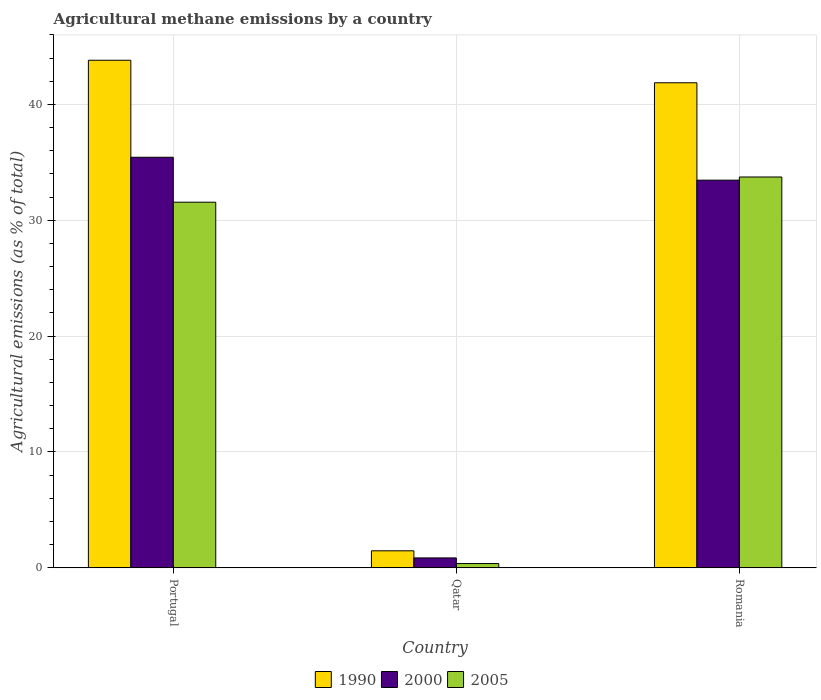How many different coloured bars are there?
Your response must be concise. 3. What is the label of the 3rd group of bars from the left?
Your response must be concise. Romania. In how many cases, is the number of bars for a given country not equal to the number of legend labels?
Your response must be concise. 0. What is the amount of agricultural methane emitted in 1990 in Romania?
Provide a succinct answer. 41.87. Across all countries, what is the maximum amount of agricultural methane emitted in 2005?
Keep it short and to the point. 33.74. Across all countries, what is the minimum amount of agricultural methane emitted in 1990?
Ensure brevity in your answer.  1.46. In which country was the amount of agricultural methane emitted in 2000 maximum?
Offer a very short reply. Portugal. In which country was the amount of agricultural methane emitted in 2005 minimum?
Your answer should be very brief. Qatar. What is the total amount of agricultural methane emitted in 2000 in the graph?
Ensure brevity in your answer.  69.75. What is the difference between the amount of agricultural methane emitted in 2005 in Qatar and that in Romania?
Your answer should be compact. -33.38. What is the difference between the amount of agricultural methane emitted in 2000 in Romania and the amount of agricultural methane emitted in 2005 in Qatar?
Ensure brevity in your answer.  33.1. What is the average amount of agricultural methane emitted in 2005 per country?
Your answer should be very brief. 21.89. What is the difference between the amount of agricultural methane emitted of/in 2005 and amount of agricultural methane emitted of/in 2000 in Romania?
Provide a short and direct response. 0.27. In how many countries, is the amount of agricultural methane emitted in 2005 greater than 2 %?
Keep it short and to the point. 2. What is the ratio of the amount of agricultural methane emitted in 2000 in Portugal to that in Qatar?
Ensure brevity in your answer.  41.75. Is the amount of agricultural methane emitted in 2000 in Portugal less than that in Romania?
Offer a very short reply. No. Is the difference between the amount of agricultural methane emitted in 2005 in Portugal and Romania greater than the difference between the amount of agricultural methane emitted in 2000 in Portugal and Romania?
Provide a succinct answer. No. What is the difference between the highest and the second highest amount of agricultural methane emitted in 2005?
Offer a very short reply. -33.38. What is the difference between the highest and the lowest amount of agricultural methane emitted in 2000?
Ensure brevity in your answer.  34.59. In how many countries, is the amount of agricultural methane emitted in 2005 greater than the average amount of agricultural methane emitted in 2005 taken over all countries?
Ensure brevity in your answer.  2. Is the sum of the amount of agricultural methane emitted in 2000 in Portugal and Romania greater than the maximum amount of agricultural methane emitted in 2005 across all countries?
Your answer should be compact. Yes. What does the 2nd bar from the left in Qatar represents?
Offer a very short reply. 2000. How many bars are there?
Your response must be concise. 9. Are all the bars in the graph horizontal?
Your answer should be compact. No. How many countries are there in the graph?
Offer a terse response. 3. Where does the legend appear in the graph?
Keep it short and to the point. Bottom center. How are the legend labels stacked?
Provide a succinct answer. Horizontal. What is the title of the graph?
Keep it short and to the point. Agricultural methane emissions by a country. What is the label or title of the X-axis?
Offer a very short reply. Country. What is the label or title of the Y-axis?
Your response must be concise. Agricultural emissions (as % of total). What is the Agricultural emissions (as % of total) of 1990 in Portugal?
Keep it short and to the point. 43.82. What is the Agricultural emissions (as % of total) of 2000 in Portugal?
Provide a short and direct response. 35.44. What is the Agricultural emissions (as % of total) of 2005 in Portugal?
Your response must be concise. 31.56. What is the Agricultural emissions (as % of total) in 1990 in Qatar?
Offer a very short reply. 1.46. What is the Agricultural emissions (as % of total) in 2000 in Qatar?
Ensure brevity in your answer.  0.85. What is the Agricultural emissions (as % of total) in 2005 in Qatar?
Your answer should be very brief. 0.36. What is the Agricultural emissions (as % of total) of 1990 in Romania?
Your response must be concise. 41.87. What is the Agricultural emissions (as % of total) in 2000 in Romania?
Your answer should be compact. 33.46. What is the Agricultural emissions (as % of total) of 2005 in Romania?
Your response must be concise. 33.74. Across all countries, what is the maximum Agricultural emissions (as % of total) in 1990?
Your answer should be very brief. 43.82. Across all countries, what is the maximum Agricultural emissions (as % of total) of 2000?
Keep it short and to the point. 35.44. Across all countries, what is the maximum Agricultural emissions (as % of total) in 2005?
Offer a very short reply. 33.74. Across all countries, what is the minimum Agricultural emissions (as % of total) in 1990?
Offer a very short reply. 1.46. Across all countries, what is the minimum Agricultural emissions (as % of total) of 2000?
Offer a very short reply. 0.85. Across all countries, what is the minimum Agricultural emissions (as % of total) in 2005?
Provide a succinct answer. 0.36. What is the total Agricultural emissions (as % of total) of 1990 in the graph?
Provide a succinct answer. 87.15. What is the total Agricultural emissions (as % of total) of 2000 in the graph?
Your answer should be very brief. 69.75. What is the total Agricultural emissions (as % of total) in 2005 in the graph?
Provide a succinct answer. 65.66. What is the difference between the Agricultural emissions (as % of total) of 1990 in Portugal and that in Qatar?
Keep it short and to the point. 42.35. What is the difference between the Agricultural emissions (as % of total) of 2000 in Portugal and that in Qatar?
Give a very brief answer. 34.59. What is the difference between the Agricultural emissions (as % of total) of 2005 in Portugal and that in Qatar?
Offer a very short reply. 31.2. What is the difference between the Agricultural emissions (as % of total) in 1990 in Portugal and that in Romania?
Provide a short and direct response. 1.94. What is the difference between the Agricultural emissions (as % of total) in 2000 in Portugal and that in Romania?
Make the answer very short. 1.98. What is the difference between the Agricultural emissions (as % of total) of 2005 in Portugal and that in Romania?
Give a very brief answer. -2.18. What is the difference between the Agricultural emissions (as % of total) in 1990 in Qatar and that in Romania?
Offer a terse response. -40.41. What is the difference between the Agricultural emissions (as % of total) of 2000 in Qatar and that in Romania?
Offer a terse response. -32.62. What is the difference between the Agricultural emissions (as % of total) of 2005 in Qatar and that in Romania?
Offer a very short reply. -33.38. What is the difference between the Agricultural emissions (as % of total) in 1990 in Portugal and the Agricultural emissions (as % of total) in 2000 in Qatar?
Provide a short and direct response. 42.97. What is the difference between the Agricultural emissions (as % of total) in 1990 in Portugal and the Agricultural emissions (as % of total) in 2005 in Qatar?
Your response must be concise. 43.45. What is the difference between the Agricultural emissions (as % of total) in 2000 in Portugal and the Agricultural emissions (as % of total) in 2005 in Qatar?
Offer a very short reply. 35.08. What is the difference between the Agricultural emissions (as % of total) of 1990 in Portugal and the Agricultural emissions (as % of total) of 2000 in Romania?
Make the answer very short. 10.35. What is the difference between the Agricultural emissions (as % of total) in 1990 in Portugal and the Agricultural emissions (as % of total) in 2005 in Romania?
Ensure brevity in your answer.  10.08. What is the difference between the Agricultural emissions (as % of total) of 2000 in Portugal and the Agricultural emissions (as % of total) of 2005 in Romania?
Ensure brevity in your answer.  1.7. What is the difference between the Agricultural emissions (as % of total) of 1990 in Qatar and the Agricultural emissions (as % of total) of 2000 in Romania?
Provide a short and direct response. -32. What is the difference between the Agricultural emissions (as % of total) in 1990 in Qatar and the Agricultural emissions (as % of total) in 2005 in Romania?
Provide a succinct answer. -32.27. What is the difference between the Agricultural emissions (as % of total) of 2000 in Qatar and the Agricultural emissions (as % of total) of 2005 in Romania?
Offer a very short reply. -32.89. What is the average Agricultural emissions (as % of total) in 1990 per country?
Provide a short and direct response. 29.05. What is the average Agricultural emissions (as % of total) in 2000 per country?
Provide a short and direct response. 23.25. What is the average Agricultural emissions (as % of total) in 2005 per country?
Keep it short and to the point. 21.89. What is the difference between the Agricultural emissions (as % of total) of 1990 and Agricultural emissions (as % of total) of 2000 in Portugal?
Your response must be concise. 8.38. What is the difference between the Agricultural emissions (as % of total) in 1990 and Agricultural emissions (as % of total) in 2005 in Portugal?
Ensure brevity in your answer.  12.26. What is the difference between the Agricultural emissions (as % of total) in 2000 and Agricultural emissions (as % of total) in 2005 in Portugal?
Provide a short and direct response. 3.88. What is the difference between the Agricultural emissions (as % of total) in 1990 and Agricultural emissions (as % of total) in 2000 in Qatar?
Offer a very short reply. 0.61. What is the difference between the Agricultural emissions (as % of total) in 1990 and Agricultural emissions (as % of total) in 2005 in Qatar?
Provide a short and direct response. 1.1. What is the difference between the Agricultural emissions (as % of total) in 2000 and Agricultural emissions (as % of total) in 2005 in Qatar?
Provide a short and direct response. 0.49. What is the difference between the Agricultural emissions (as % of total) of 1990 and Agricultural emissions (as % of total) of 2000 in Romania?
Offer a very short reply. 8.41. What is the difference between the Agricultural emissions (as % of total) in 1990 and Agricultural emissions (as % of total) in 2005 in Romania?
Ensure brevity in your answer.  8.13. What is the difference between the Agricultural emissions (as % of total) in 2000 and Agricultural emissions (as % of total) in 2005 in Romania?
Your response must be concise. -0.27. What is the ratio of the Agricultural emissions (as % of total) of 1990 in Portugal to that in Qatar?
Your response must be concise. 29.94. What is the ratio of the Agricultural emissions (as % of total) of 2000 in Portugal to that in Qatar?
Your answer should be compact. 41.75. What is the ratio of the Agricultural emissions (as % of total) of 2005 in Portugal to that in Qatar?
Give a very brief answer. 87.01. What is the ratio of the Agricultural emissions (as % of total) of 1990 in Portugal to that in Romania?
Your response must be concise. 1.05. What is the ratio of the Agricultural emissions (as % of total) in 2000 in Portugal to that in Romania?
Make the answer very short. 1.06. What is the ratio of the Agricultural emissions (as % of total) of 2005 in Portugal to that in Romania?
Ensure brevity in your answer.  0.94. What is the ratio of the Agricultural emissions (as % of total) of 1990 in Qatar to that in Romania?
Give a very brief answer. 0.04. What is the ratio of the Agricultural emissions (as % of total) in 2000 in Qatar to that in Romania?
Provide a short and direct response. 0.03. What is the ratio of the Agricultural emissions (as % of total) of 2005 in Qatar to that in Romania?
Your response must be concise. 0.01. What is the difference between the highest and the second highest Agricultural emissions (as % of total) in 1990?
Your response must be concise. 1.94. What is the difference between the highest and the second highest Agricultural emissions (as % of total) in 2000?
Provide a succinct answer. 1.98. What is the difference between the highest and the second highest Agricultural emissions (as % of total) of 2005?
Provide a succinct answer. 2.18. What is the difference between the highest and the lowest Agricultural emissions (as % of total) of 1990?
Your answer should be very brief. 42.35. What is the difference between the highest and the lowest Agricultural emissions (as % of total) in 2000?
Offer a very short reply. 34.59. What is the difference between the highest and the lowest Agricultural emissions (as % of total) of 2005?
Ensure brevity in your answer.  33.38. 